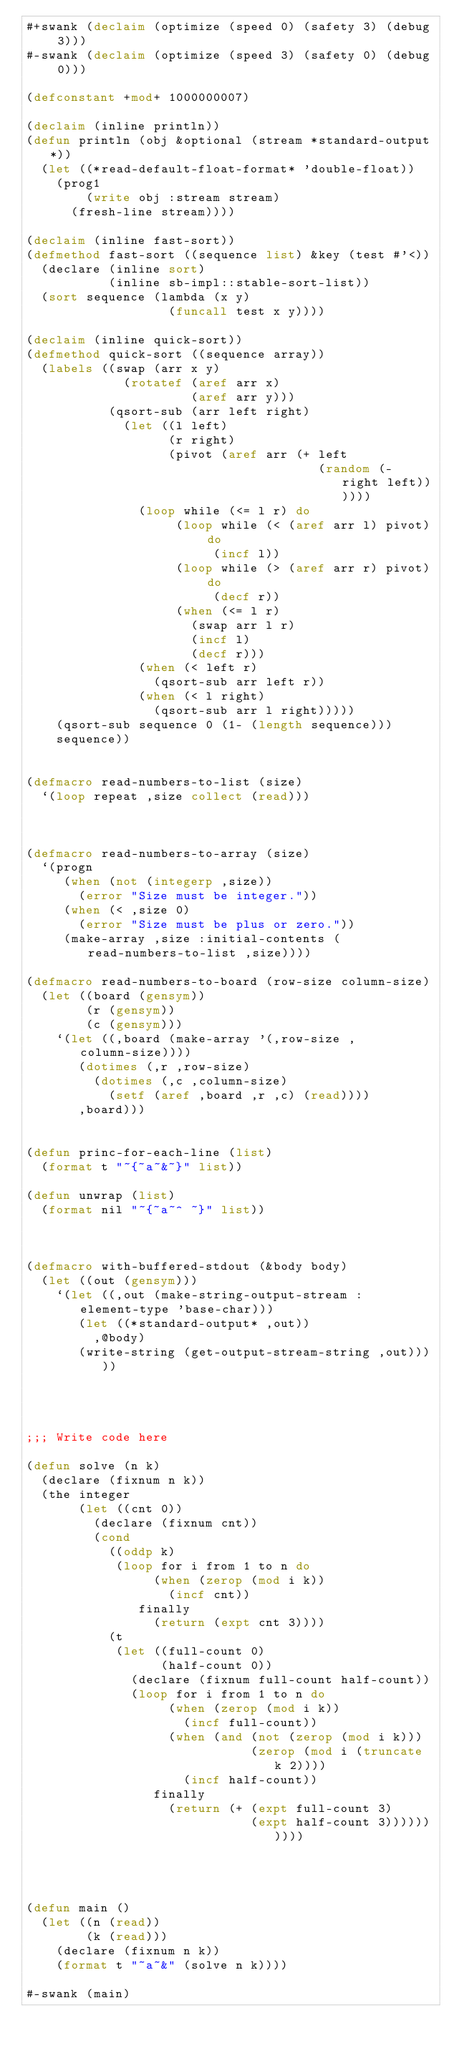Convert code to text. <code><loc_0><loc_0><loc_500><loc_500><_Lisp_>#+swank (declaim (optimize (speed 0) (safety 3) (debug 3)))
#-swank (declaim (optimize (speed 3) (safety 0) (debug 0)))

(defconstant +mod+ 1000000007)

(declaim (inline println))
(defun println (obj &optional (stream *standard-output*))
  (let ((*read-default-float-format* 'double-float))
    (prog1
        (write obj :stream stream)
      (fresh-line stream))))

(declaim (inline fast-sort))
(defmethod fast-sort ((sequence list) &key (test #'<))
  (declare (inline sort)
           (inline sb-impl::stable-sort-list))
  (sort sequence (lambda (x y)
                   (funcall test x y))))

(declaim (inline quick-sort))
(defmethod quick-sort ((sequence array))
  (labels ((swap (arr x y)
             (rotatef (aref arr x)
                      (aref arr y)))
           (qsort-sub (arr left right)
             (let ((l left)
                   (r right)
                   (pivot (aref arr (+ left
                                       (random (- right left))))))
               (loop while (<= l r) do
                    (loop while (< (aref arr l) pivot) do
                         (incf l))
                    (loop while (> (aref arr r) pivot) do
                         (decf r))
                    (when (<= l r)
                      (swap arr l r)
                      (incf l)
                      (decf r)))
               (when (< left r)
                 (qsort-sub arr left r))
               (when (< l right)
                 (qsort-sub arr l right)))))
    (qsort-sub sequence 0 (1- (length sequence)))
    sequence))


(defmacro read-numbers-to-list (size)
  `(loop repeat ,size collect (read)))



(defmacro read-numbers-to-array (size)
  `(progn
     (when (not (integerp ,size))
       (error "Size must be integer."))
     (when (< ,size 0)
       (error "Size must be plus or zero."))
     (make-array ,size :initial-contents (read-numbers-to-list ,size))))

(defmacro read-numbers-to-board (row-size column-size)
  (let ((board (gensym))
        (r (gensym))
        (c (gensym)))
    `(let ((,board (make-array '(,row-size ,column-size))))
       (dotimes (,r ,row-size)
         (dotimes (,c ,column-size)
           (setf (aref ,board ,r ,c) (read))))
       ,board)))


(defun princ-for-each-line (list)
  (format t "~{~a~&~}" list))

(defun unwrap (list)
  (format nil "~{~a~^ ~}" list))



(defmacro with-buffered-stdout (&body body)
  (let ((out (gensym)))
    `(let ((,out (make-string-output-stream :element-type 'base-char)))
       (let ((*standard-output* ,out))
         ,@body)
       (write-string (get-output-stream-string ,out)))))




;;; Write code here

(defun solve (n k)
  (declare (fixnum n k))
  (the integer
       (let ((cnt 0))
         (declare (fixnum cnt))
         (cond
           ((oddp k)
            (loop for i from 1 to n do
                 (when (zerop (mod i k))
                   (incf cnt))
               finally
                 (return (expt cnt 3))))
           (t
            (let ((full-count 0)
                  (half-count 0))
              (declare (fixnum full-count half-count))
              (loop for i from 1 to n do
                   (when (zerop (mod i k))
                     (incf full-count))
                   (when (and (not (zerop (mod i k)))
                              (zerop (mod i (truncate k 2))))
                     (incf half-count))
                 finally
                   (return (+ (expt full-count 3)
                              (expt half-count 3))))))))))



       
(defun main ()
  (let ((n (read))
        (k (read)))
    (declare (fixnum n k))
    (format t "~a~&" (solve n k))))

#-swank (main)
</code> 